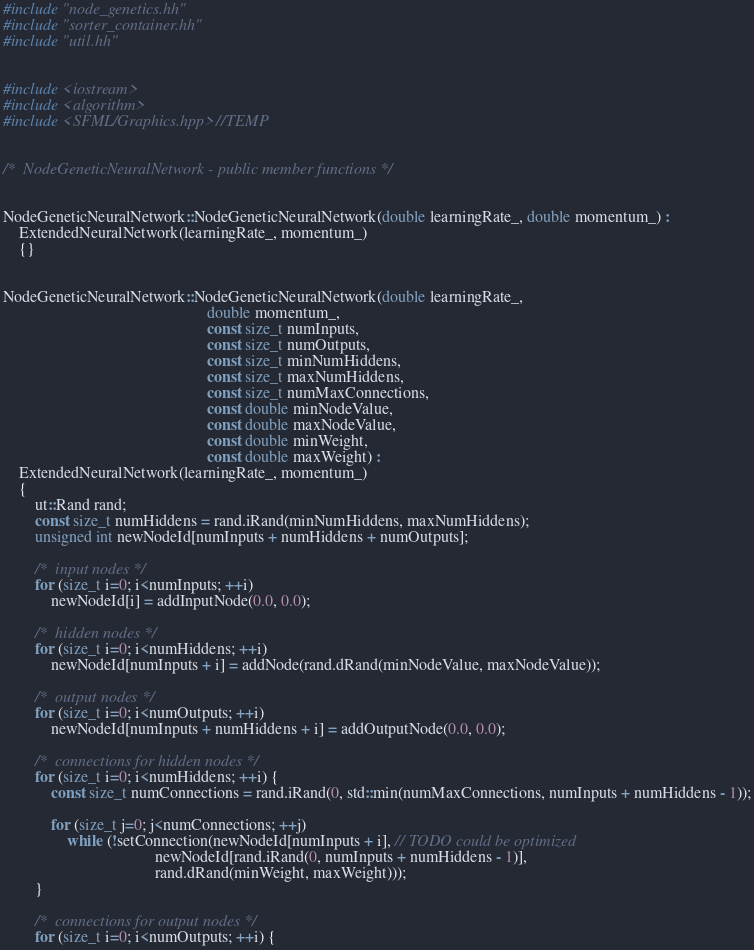<code> <loc_0><loc_0><loc_500><loc_500><_C++_>#include "node_genetics.hh"
#include "sorter_container.hh"
#include "util.hh"


#include <iostream>
#include <algorithm>
#include <SFML/Graphics.hpp> //TEMP


/*  NodeGeneticNeuralNetwork - public member functions */


NodeGeneticNeuralNetwork::NodeGeneticNeuralNetwork(double learningRate_, double momentum_) :
    ExtendedNeuralNetwork(learningRate_, momentum_)
    {}


NodeGeneticNeuralNetwork::NodeGeneticNeuralNetwork(double learningRate_,
                                                   double momentum_,
                                                   const size_t numInputs,
                                                   const size_t numOutputs,
                                                   const size_t minNumHiddens,
                                                   const size_t maxNumHiddens,
                                                   const size_t numMaxConnections,
                                                   const double minNodeValue,
                                                   const double maxNodeValue,
                                                   const double minWeight,
                                                   const double maxWeight) :
    ExtendedNeuralNetwork(learningRate_, momentum_)
    {
        ut::Rand rand;
        const size_t numHiddens = rand.iRand(minNumHiddens, maxNumHiddens);
        unsigned int newNodeId[numInputs + numHiddens + numOutputs];

        /*  input nodes */
        for (size_t i=0; i<numInputs; ++i)
            newNodeId[i] = addInputNode(0.0, 0.0);

        /*  hidden nodes */
        for (size_t i=0; i<numHiddens; ++i)
            newNodeId[numInputs + i] = addNode(rand.dRand(minNodeValue, maxNodeValue));

        /*  output nodes */
        for (size_t i=0; i<numOutputs; ++i)
            newNodeId[numInputs + numHiddens + i] = addOutputNode(0.0, 0.0);

        /*  connections for hidden nodes */
        for (size_t i=0; i<numHiddens; ++i) {
            const size_t numConnections = rand.iRand(0, std::min(numMaxConnections, numInputs + numHiddens - 1));

            for (size_t j=0; j<numConnections; ++j)
                while (!setConnection(newNodeId[numInputs + i], // TODO could be optimized
                                      newNodeId[rand.iRand(0, numInputs + numHiddens - 1)],
                                      rand.dRand(minWeight, maxWeight)));
        }

        /*  connections for output nodes */
        for (size_t i=0; i<numOutputs; ++i) {</code> 